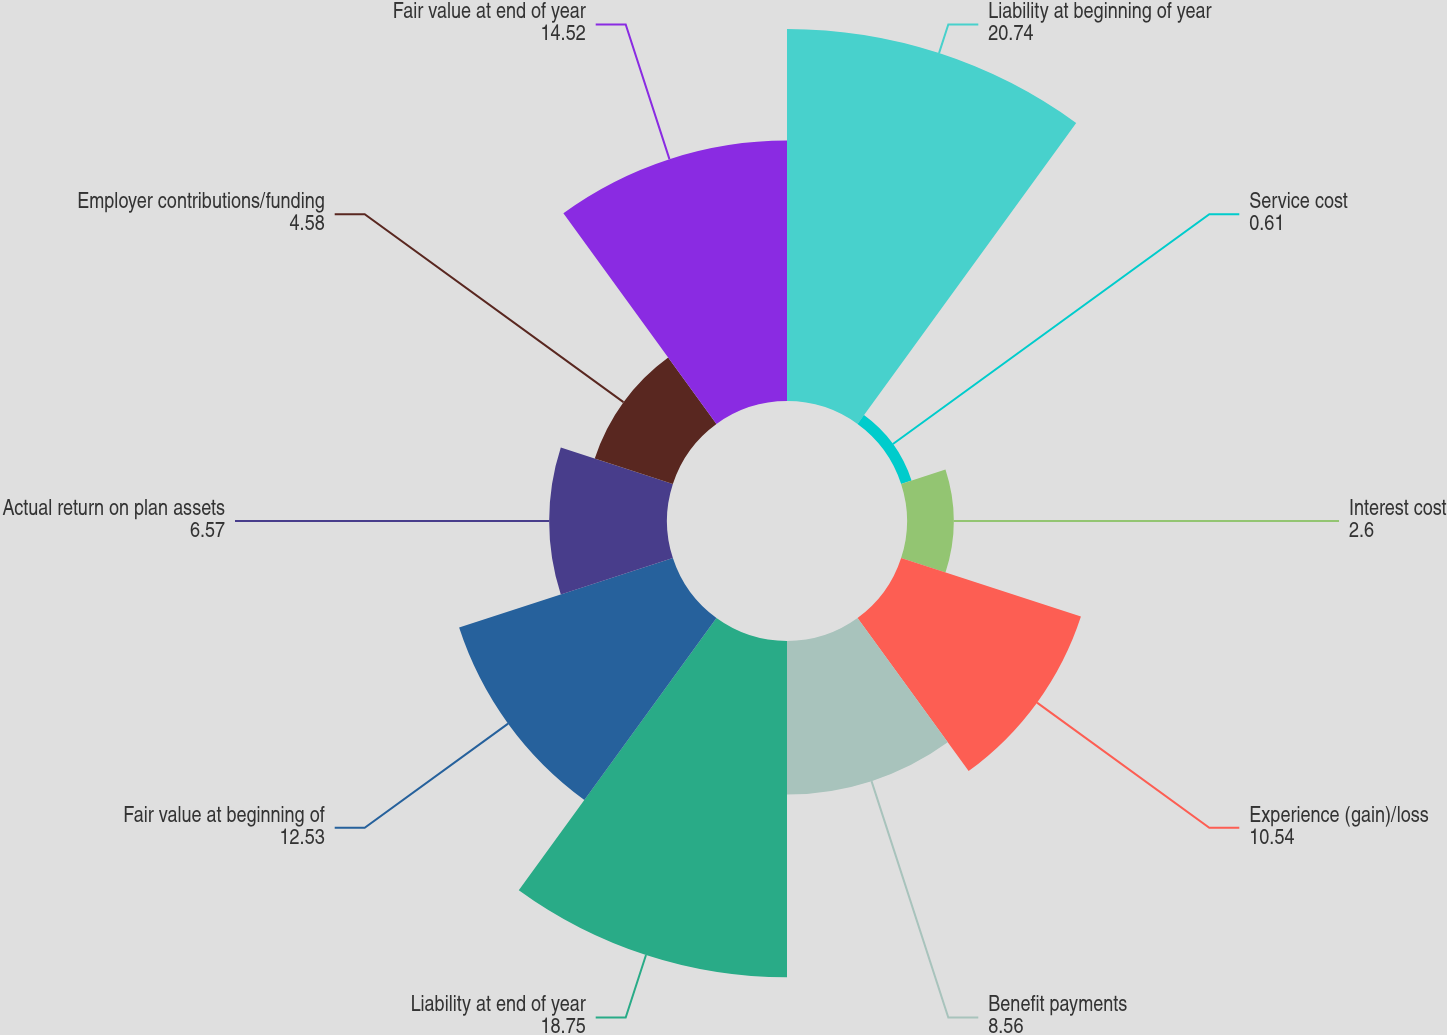<chart> <loc_0><loc_0><loc_500><loc_500><pie_chart><fcel>Liability at beginning of year<fcel>Service cost<fcel>Interest cost<fcel>Experience (gain)/loss<fcel>Benefit payments<fcel>Liability at end of year<fcel>Fair value at beginning of<fcel>Actual return on plan assets<fcel>Employer contributions/funding<fcel>Fair value at end of year<nl><fcel>20.74%<fcel>0.61%<fcel>2.6%<fcel>10.54%<fcel>8.56%<fcel>18.75%<fcel>12.53%<fcel>6.57%<fcel>4.58%<fcel>14.52%<nl></chart> 